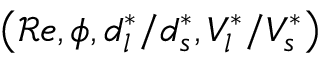<formula> <loc_0><loc_0><loc_500><loc_500>\left ( { \mathcal { R } e } , \phi , d _ { l } ^ { * } / d _ { s } ^ { * } , V _ { l } ^ { * } / V _ { s } ^ { * } \right )</formula> 